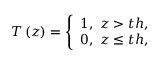Convert formula to latex. <formula><loc_0><loc_0><loc_500><loc_500>T \left ( z \right ) = \left \{ \begin{array} { r } { 1 , \ z > t h , } \\ { 0 , \ z \leq t h , } \end{array}</formula> 